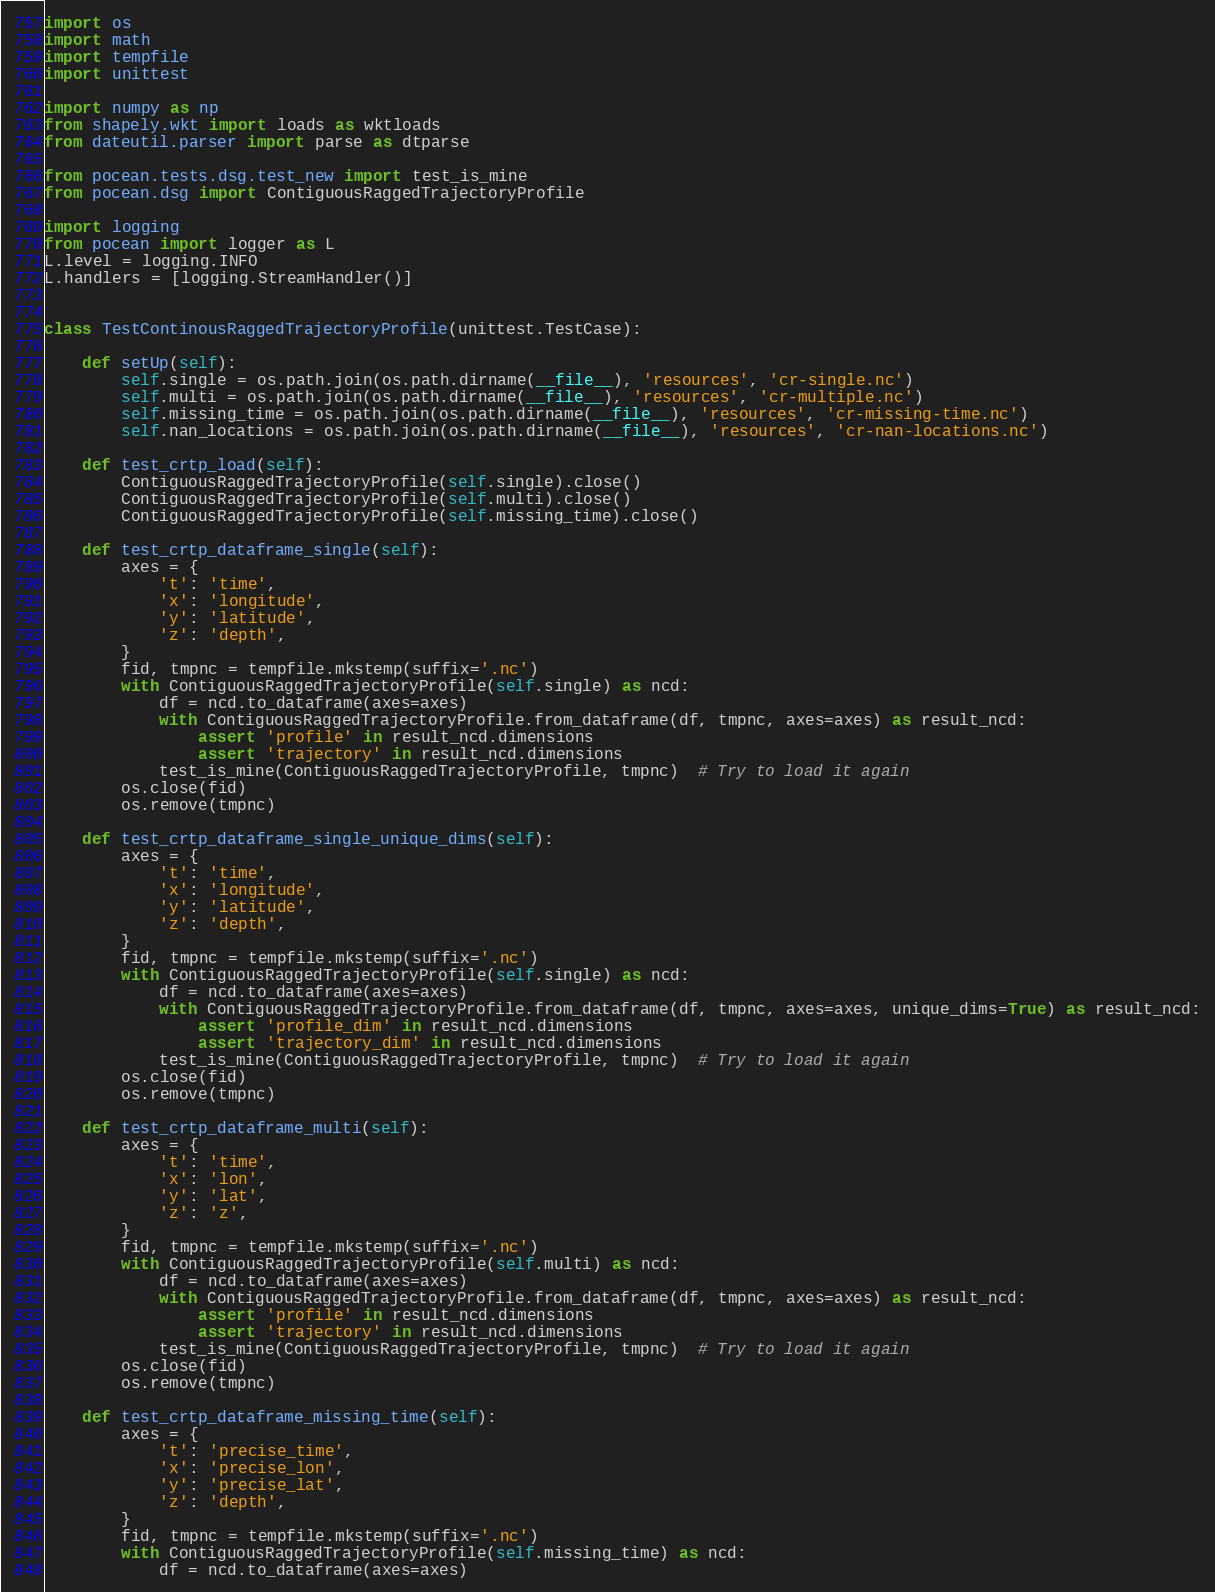<code> <loc_0><loc_0><loc_500><loc_500><_Python_>import os
import math
import tempfile
import unittest

import numpy as np
from shapely.wkt import loads as wktloads
from dateutil.parser import parse as dtparse

from pocean.tests.dsg.test_new import test_is_mine
from pocean.dsg import ContiguousRaggedTrajectoryProfile

import logging
from pocean import logger as L
L.level = logging.INFO
L.handlers = [logging.StreamHandler()]


class TestContinousRaggedTrajectoryProfile(unittest.TestCase):

    def setUp(self):
        self.single = os.path.join(os.path.dirname(__file__), 'resources', 'cr-single.nc')
        self.multi = os.path.join(os.path.dirname(__file__), 'resources', 'cr-multiple.nc')
        self.missing_time = os.path.join(os.path.dirname(__file__), 'resources', 'cr-missing-time.nc')
        self.nan_locations = os.path.join(os.path.dirname(__file__), 'resources', 'cr-nan-locations.nc')

    def test_crtp_load(self):
        ContiguousRaggedTrajectoryProfile(self.single).close()
        ContiguousRaggedTrajectoryProfile(self.multi).close()
        ContiguousRaggedTrajectoryProfile(self.missing_time).close()

    def test_crtp_dataframe_single(self):
        axes = {
            't': 'time',
            'x': 'longitude',
            'y': 'latitude',
            'z': 'depth',
        }
        fid, tmpnc = tempfile.mkstemp(suffix='.nc')
        with ContiguousRaggedTrajectoryProfile(self.single) as ncd:
            df = ncd.to_dataframe(axes=axes)
            with ContiguousRaggedTrajectoryProfile.from_dataframe(df, tmpnc, axes=axes) as result_ncd:
                assert 'profile' in result_ncd.dimensions
                assert 'trajectory' in result_ncd.dimensions
            test_is_mine(ContiguousRaggedTrajectoryProfile, tmpnc)  # Try to load it again
        os.close(fid)
        os.remove(tmpnc)

    def test_crtp_dataframe_single_unique_dims(self):
        axes = {
            't': 'time',
            'x': 'longitude',
            'y': 'latitude',
            'z': 'depth',
        }
        fid, tmpnc = tempfile.mkstemp(suffix='.nc')
        with ContiguousRaggedTrajectoryProfile(self.single) as ncd:
            df = ncd.to_dataframe(axes=axes)
            with ContiguousRaggedTrajectoryProfile.from_dataframe(df, tmpnc, axes=axes, unique_dims=True) as result_ncd:
                assert 'profile_dim' in result_ncd.dimensions
                assert 'trajectory_dim' in result_ncd.dimensions
            test_is_mine(ContiguousRaggedTrajectoryProfile, tmpnc)  # Try to load it again
        os.close(fid)
        os.remove(tmpnc)

    def test_crtp_dataframe_multi(self):
        axes = {
            't': 'time',
            'x': 'lon',
            'y': 'lat',
            'z': 'z',
        }
        fid, tmpnc = tempfile.mkstemp(suffix='.nc')
        with ContiguousRaggedTrajectoryProfile(self.multi) as ncd:
            df = ncd.to_dataframe(axes=axes)
            with ContiguousRaggedTrajectoryProfile.from_dataframe(df, tmpnc, axes=axes) as result_ncd:
                assert 'profile' in result_ncd.dimensions
                assert 'trajectory' in result_ncd.dimensions
            test_is_mine(ContiguousRaggedTrajectoryProfile, tmpnc)  # Try to load it again
        os.close(fid)
        os.remove(tmpnc)

    def test_crtp_dataframe_missing_time(self):
        axes = {
            't': 'precise_time',
            'x': 'precise_lon',
            'y': 'precise_lat',
            'z': 'depth',
        }
        fid, tmpnc = tempfile.mkstemp(suffix='.nc')
        with ContiguousRaggedTrajectoryProfile(self.missing_time) as ncd:
            df = ncd.to_dataframe(axes=axes)</code> 